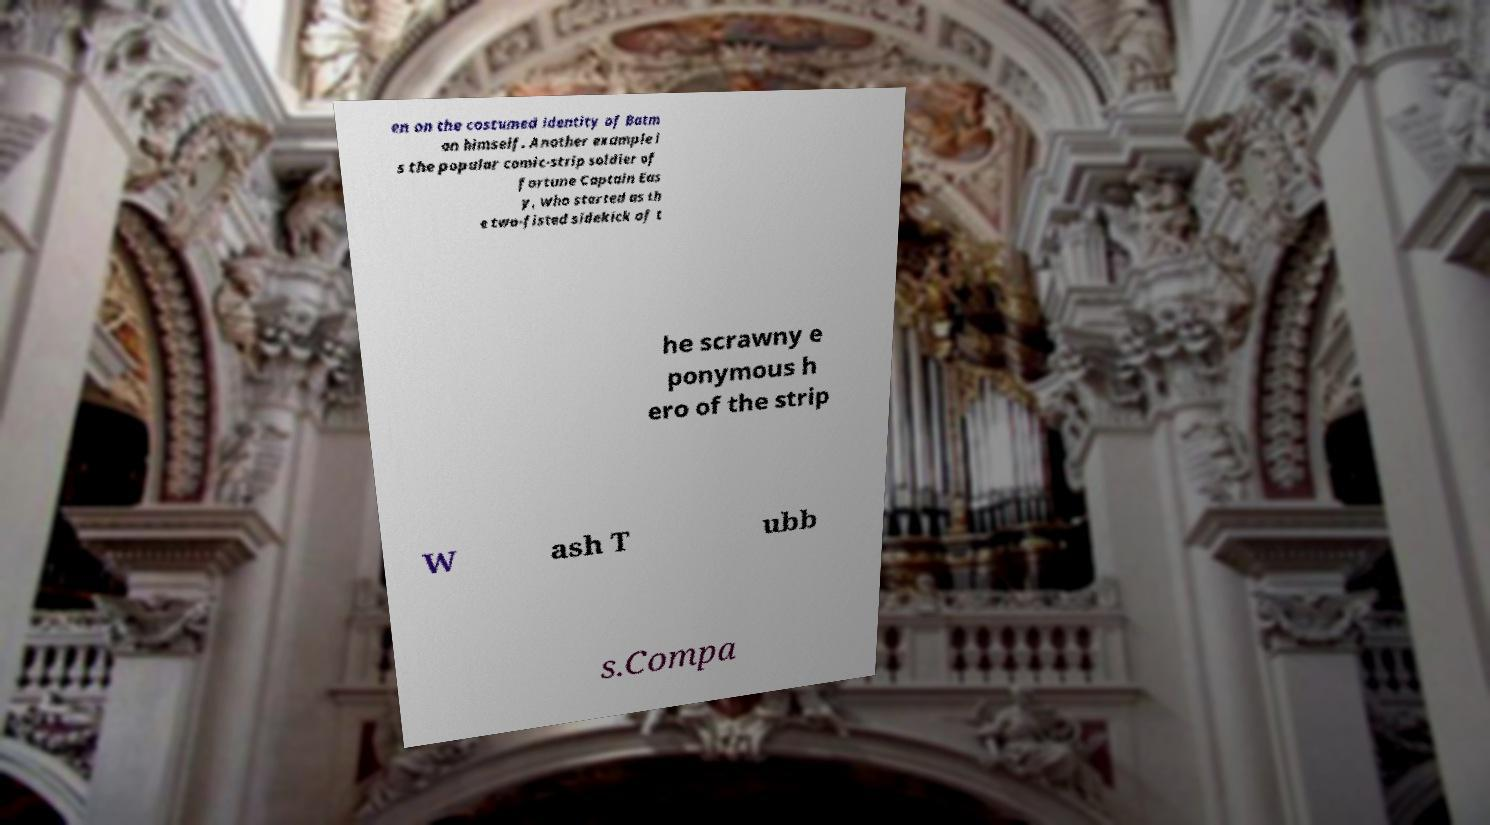For documentation purposes, I need the text within this image transcribed. Could you provide that? en on the costumed identity of Batm an himself. Another example i s the popular comic-strip soldier of fortune Captain Eas y, who started as th e two-fisted sidekick of t he scrawny e ponymous h ero of the strip W ash T ubb s.Compa 